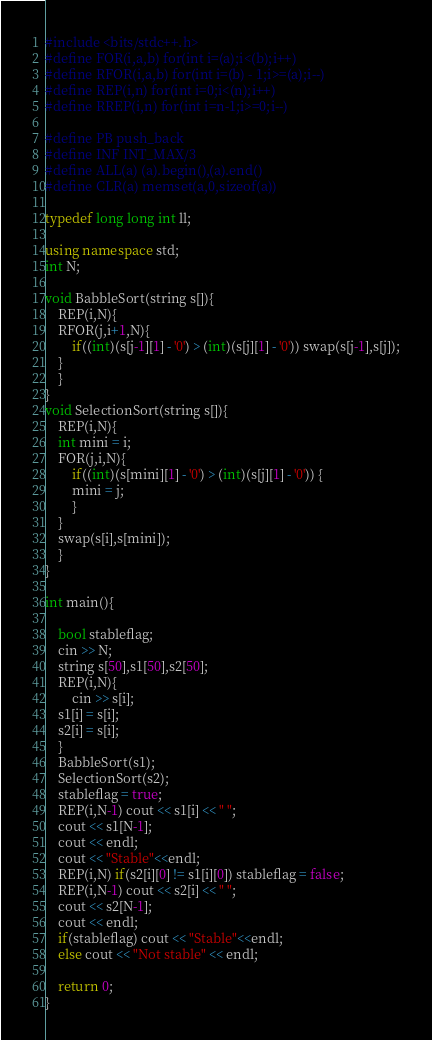Convert code to text. <code><loc_0><loc_0><loc_500><loc_500><_C++_>#include <bits/stdc++.h>
#define FOR(i,a,b) for(int i=(a);i<(b);i++)
#define RFOR(i,a,b) for(int i=(b) - 1;i>=(a);i--)
#define REP(i,n) for(int i=0;i<(n);i++)
#define RREP(i,n) for(int i=n-1;i>=0;i--)

#define PB push_back
#define INF INT_MAX/3
#define ALL(a) (a).begin(),(a).end()
#define CLR(a) memset(a,0,sizeof(a))

typedef long long int ll;

using namespace std;
int N;

void BabbleSort(string s[]){
    REP(i,N){
	RFOR(j,i+1,N){
	    if((int)(s[j-1][1] - '0') > (int)(s[j][1] - '0')) swap(s[j-1],s[j]);
	}
    }	
}
void SelectionSort(string s[]){
    REP(i,N){
	int mini = i;
	FOR(j,i,N){
	    if((int)(s[mini][1] - '0') > (int)(s[j][1] - '0')) {
		mini = j;
	    }
	}
	swap(s[i],s[mini]);
    }
}

int main(){

    bool stableflag;
    cin >> N;
    string s[50],s1[50],s2[50];
    REP(i,N){
       	cin >> s[i];
	s1[i] = s[i];
	s2[i] = s[i];
    }
    BabbleSort(s1);
    SelectionSort(s2);
    stableflag = true;
    REP(i,N-1) cout << s1[i] << " ";
    cout << s1[N-1];
    cout << endl;
    cout << "Stable"<<endl;
    REP(i,N) if(s2[i][0] != s1[i][0]) stableflag = false;
    REP(i,N-1) cout << s2[i] << " ";
    cout << s2[N-1];
    cout << endl;
    if(stableflag) cout << "Stable"<<endl;
    else cout << "Not stable" << endl;

    return 0;
}</code> 